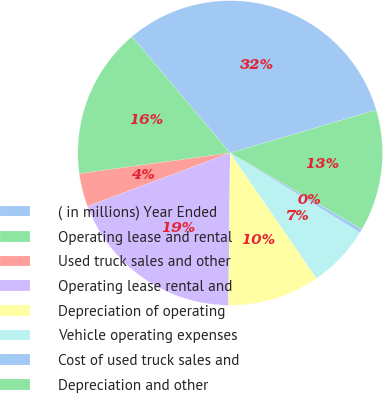Convert chart. <chart><loc_0><loc_0><loc_500><loc_500><pie_chart><fcel>( in millions) Year Ended<fcel>Operating lease and rental<fcel>Used truck sales and other<fcel>Operating lease rental and<fcel>Depreciation of operating<fcel>Vehicle operating expenses<fcel>Cost of used truck sales and<fcel>Depreciation and other<nl><fcel>31.6%<fcel>16.01%<fcel>3.53%<fcel>19.13%<fcel>9.77%<fcel>6.65%<fcel>0.41%<fcel>12.89%<nl></chart> 